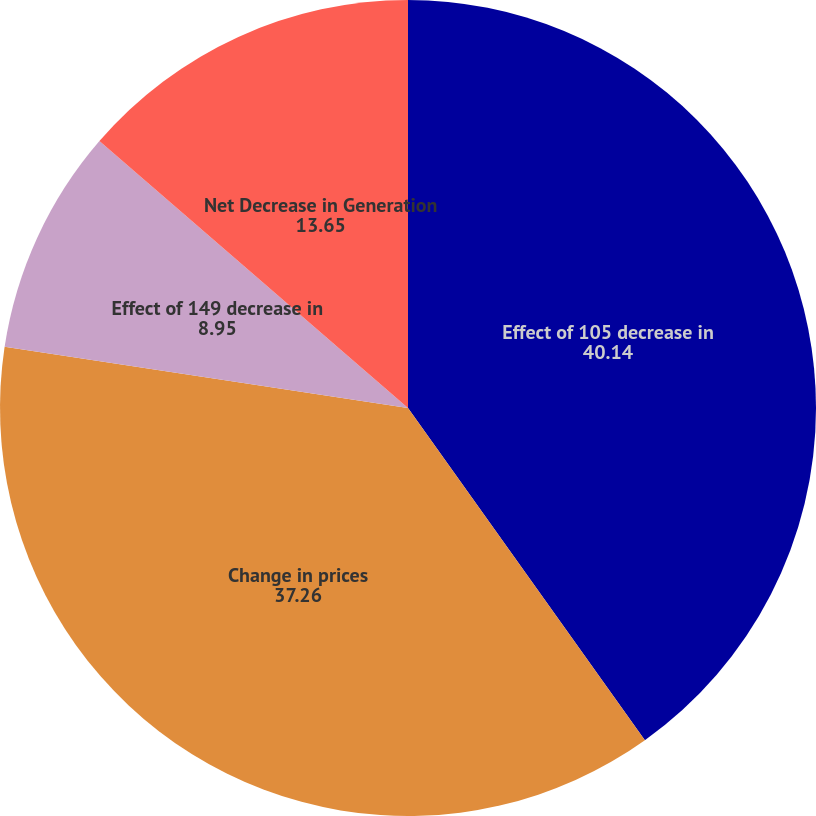Convert chart. <chart><loc_0><loc_0><loc_500><loc_500><pie_chart><fcel>Effect of 105 decrease in<fcel>Change in prices<fcel>Effect of 149 decrease in<fcel>Net Decrease in Generation<nl><fcel>40.14%<fcel>37.26%<fcel>8.95%<fcel>13.65%<nl></chart> 